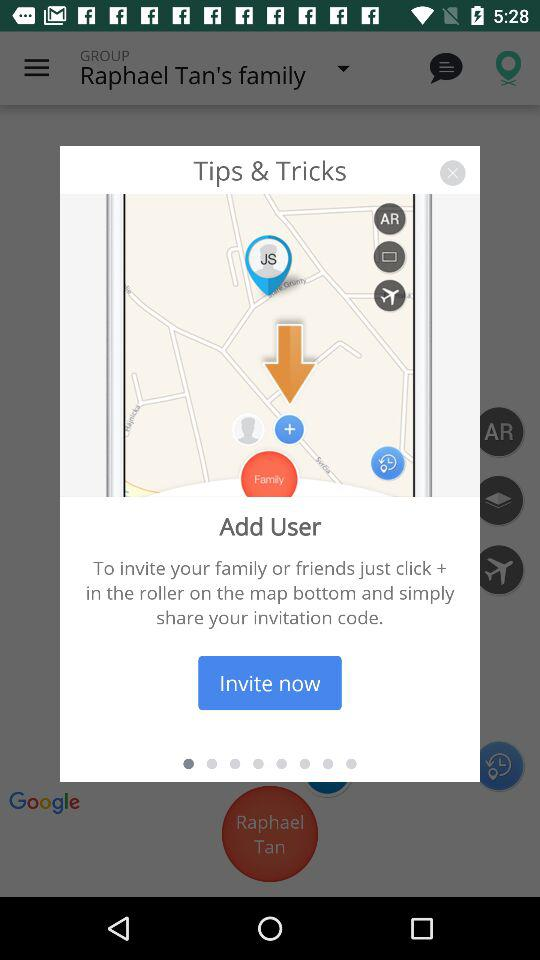Which group was selected? The selected group was Raphael Tan's family. 